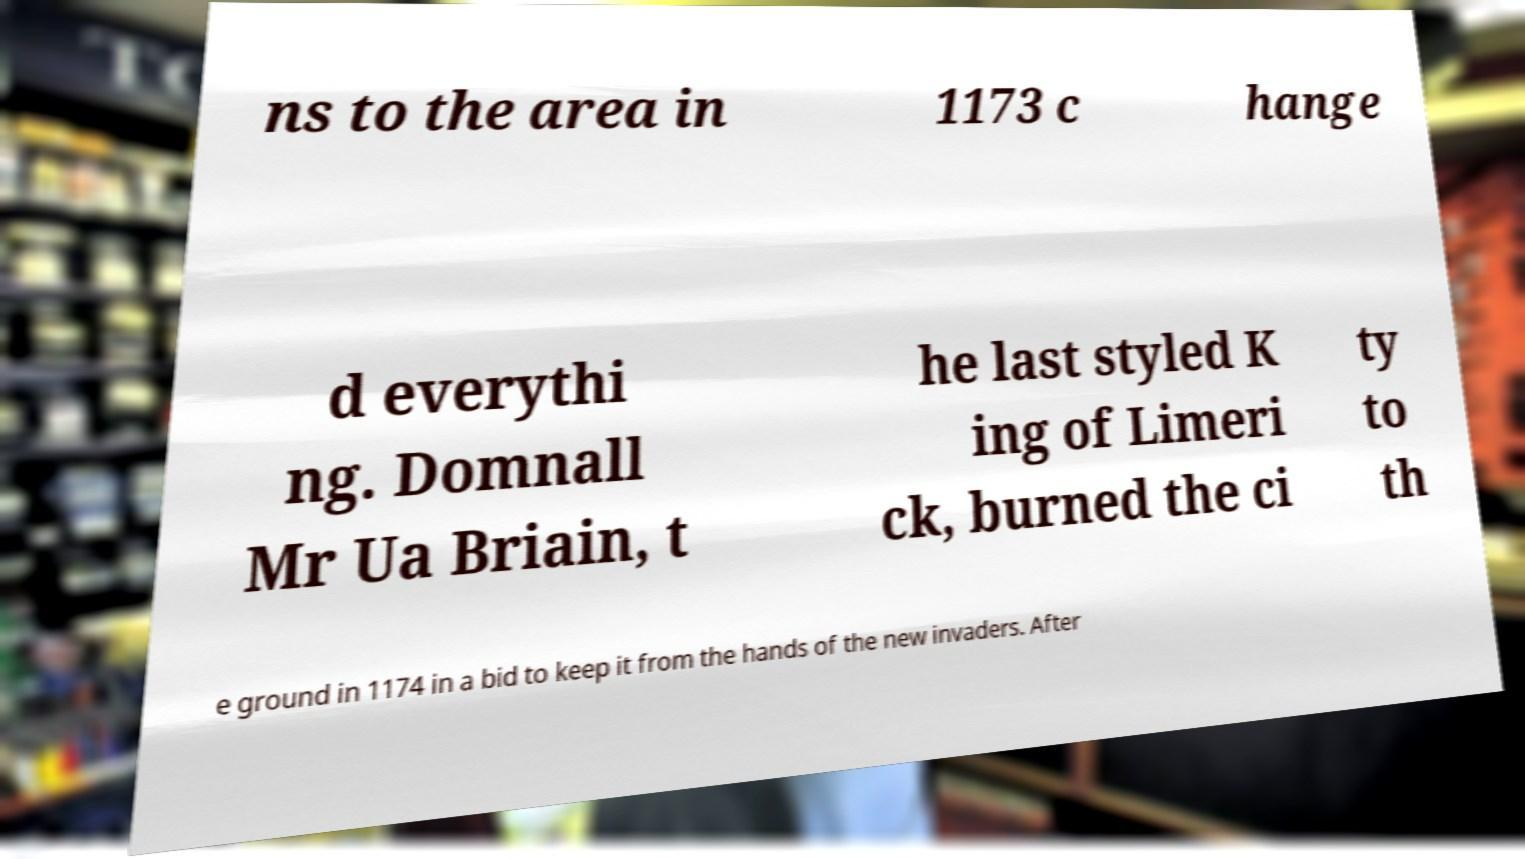Can you accurately transcribe the text from the provided image for me? ns to the area in 1173 c hange d everythi ng. Domnall Mr Ua Briain, t he last styled K ing of Limeri ck, burned the ci ty to th e ground in 1174 in a bid to keep it from the hands of the new invaders. After 